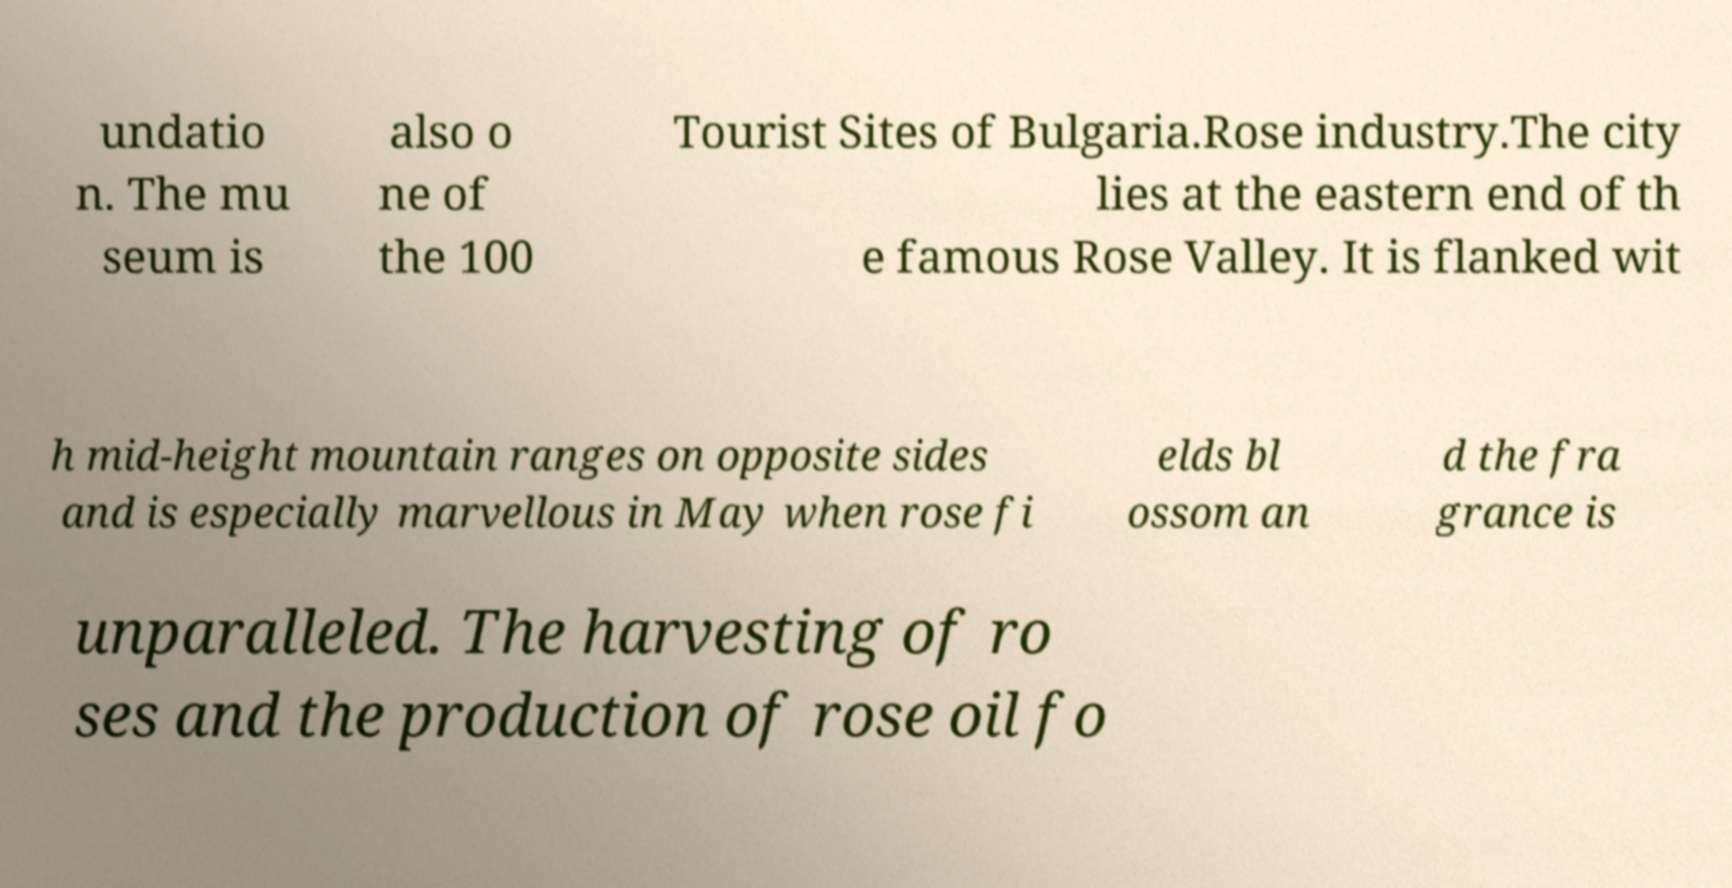For documentation purposes, I need the text within this image transcribed. Could you provide that? undatio n. The mu seum is also o ne of the 100 Tourist Sites of Bulgaria.Rose industry.The city lies at the eastern end of th e famous Rose Valley. It is flanked wit h mid-height mountain ranges on opposite sides and is especially marvellous in May when rose fi elds bl ossom an d the fra grance is unparalleled. The harvesting of ro ses and the production of rose oil fo 